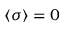<formula> <loc_0><loc_0><loc_500><loc_500>\langle \sigma \rangle = 0</formula> 